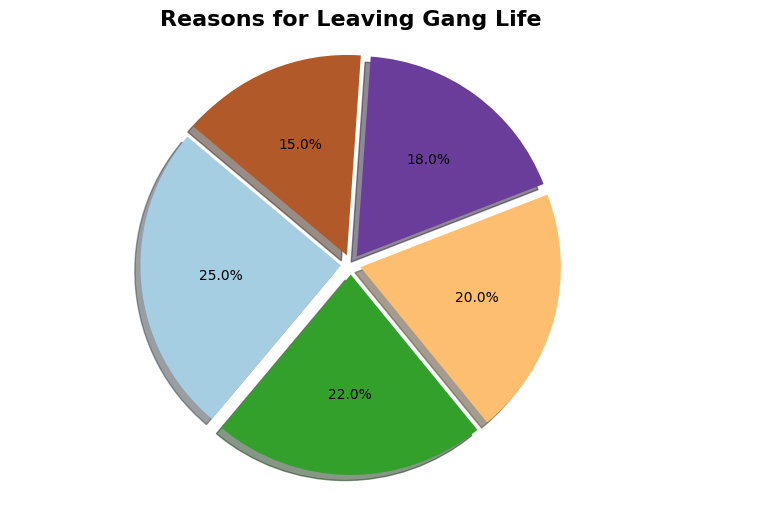what is the most common reason for leaving gang life? From the pie chart, the segment representing "Fear of Violence" has the largest percentage (25%). Therefore, the most common reason for leaving gang life, according to the chart, is fear of violence.
Answer: Fear of Violence Which reason accounts for a fifth of the total? To determine which category matches a fifth of the total, calculate 1/5 of 100%, which is 20%. From the pie chart, "Support from Loved Ones" accounts for 20%, fitting this criterion.
Answer: Support from Loved Ones Which is more common: intervention programs or legal consequences? Intervention programs account for 18% of the reasons, while legal consequences account for 15%. Since 18% is greater than 15%, intervention programs are more common than legal consequences.
Answer: Intervention Programs What is the combined percentage of the top two reasons? The top two reasons are "Fear of Violence" with 25% and "Desire for a Better Future" with 22%. Adding these percentages gives 25% + 22% = 47%.
Answer: 47% Which reason is represented by the smallest segment? From the chart, the smallest segment is "Legal Consequences," which accounts for 15% of the reasons.
Answer: Legal Consequences How much more common is fear of violence compared to support from loved ones? Fear of violence accounts for 25%, while support from loved ones accounts for 20%. The difference is 25% - 20% = 5%.
Answer: 5% What is the combined percentage of reasons related to violence and legal issues? "Fear of Violence" is 25% and "Legal Consequences" is 15%. Adding these gives 25% + 15% = 40%.
Answer: 40% Which reason has a nearly equal proportion to the combination of intervention programs and legal consequences? Intervention Programs account for 18% and Legal Consequences account for 15%. The combined percentage is 18% + 15% = 33%. Desire for a Better Future is 22%, which is not nearly equal. Therefore, no reason closely matches that proportion.
Answer: None 